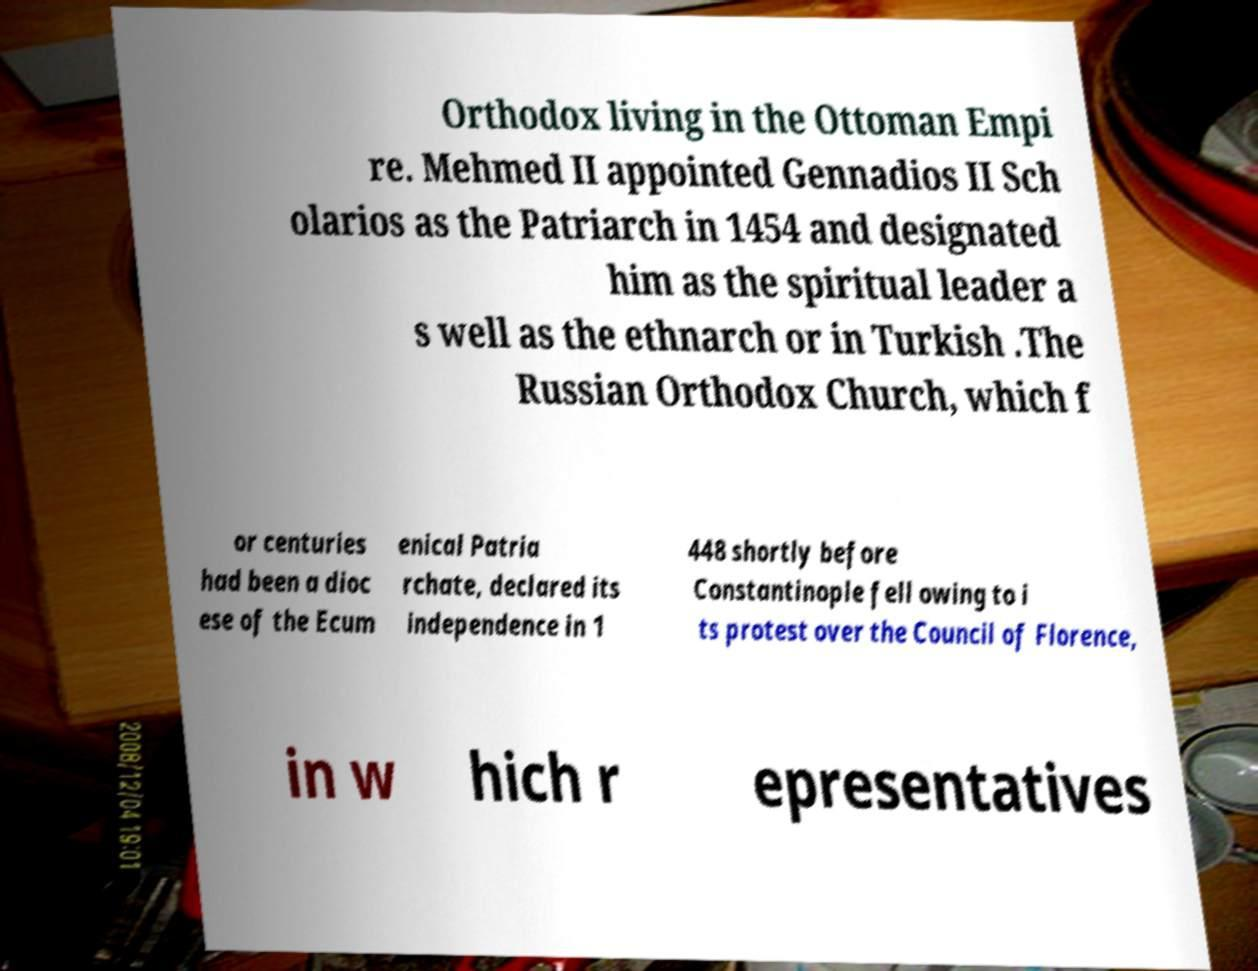What messages or text are displayed in this image? I need them in a readable, typed format. Orthodox living in the Ottoman Empi re. Mehmed II appointed Gennadios II Sch olarios as the Patriarch in 1454 and designated him as the spiritual leader a s well as the ethnarch or in Turkish .The Russian Orthodox Church, which f or centuries had been a dioc ese of the Ecum enical Patria rchate, declared its independence in 1 448 shortly before Constantinople fell owing to i ts protest over the Council of Florence, in w hich r epresentatives 